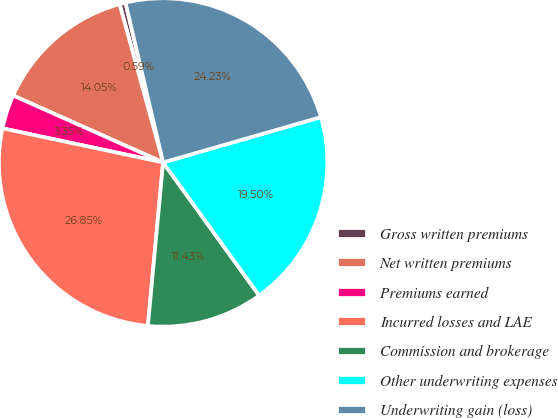<chart> <loc_0><loc_0><loc_500><loc_500><pie_chart><fcel>Gross written premiums<fcel>Net written premiums<fcel>Premiums earned<fcel>Incurred losses and LAE<fcel>Commission and brokerage<fcel>Other underwriting expenses<fcel>Underwriting gain (loss)<nl><fcel>0.59%<fcel>14.05%<fcel>3.35%<fcel>26.85%<fcel>11.43%<fcel>19.5%<fcel>24.23%<nl></chart> 